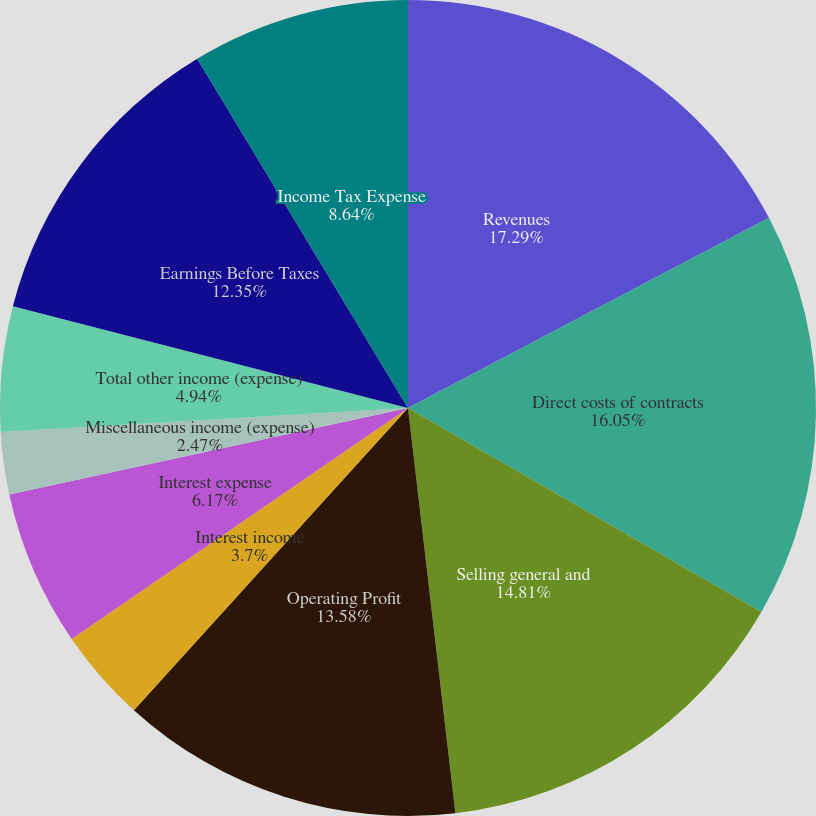Convert chart. <chart><loc_0><loc_0><loc_500><loc_500><pie_chart><fcel>Revenues<fcel>Direct costs of contracts<fcel>Selling general and<fcel>Operating Profit<fcel>Interest income<fcel>Interest expense<fcel>Miscellaneous income (expense)<fcel>Total other income (expense)<fcel>Earnings Before Taxes<fcel>Income Tax Expense<nl><fcel>17.28%<fcel>16.05%<fcel>14.81%<fcel>13.58%<fcel>3.7%<fcel>6.17%<fcel>2.47%<fcel>4.94%<fcel>12.35%<fcel>8.64%<nl></chart> 